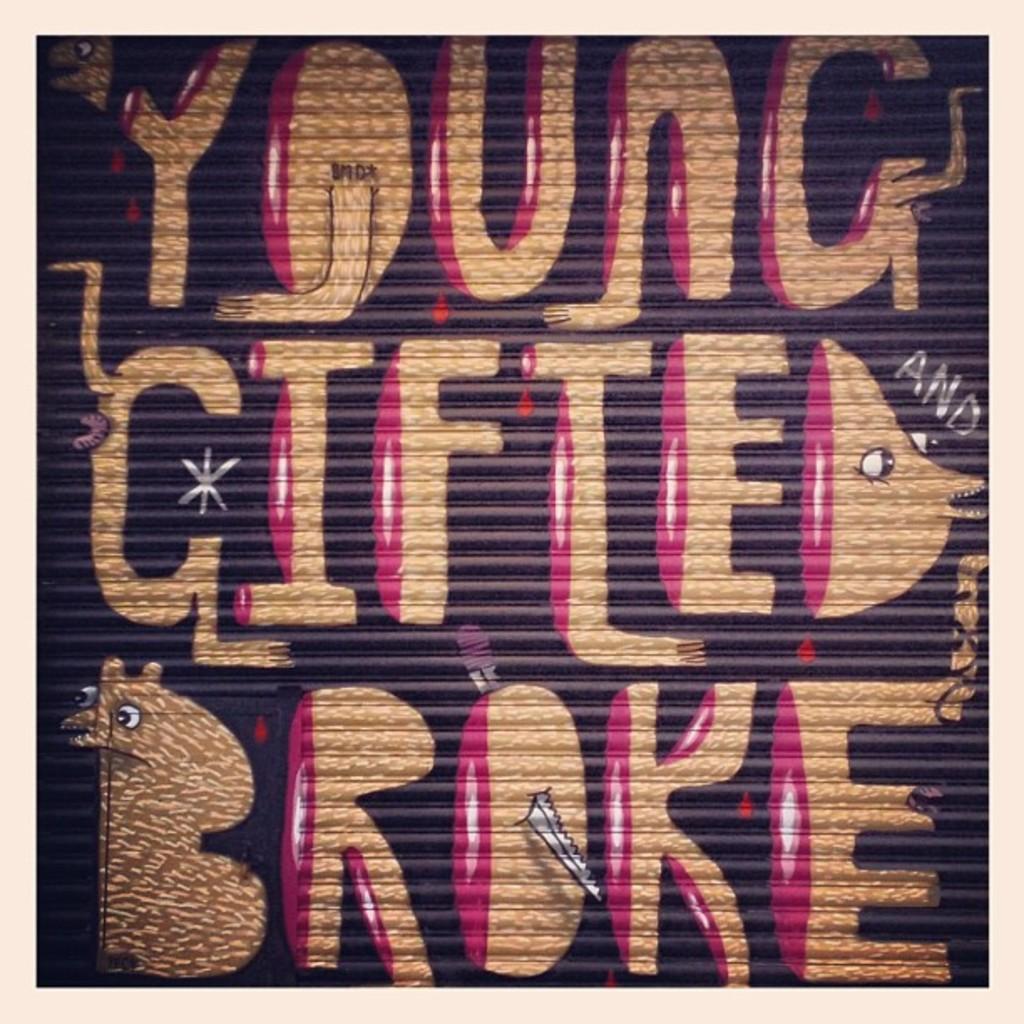What does the last word say?
Offer a terse response. Broke. What is the sentiment depicted by these words?
Offer a terse response. Young gifted broke. 